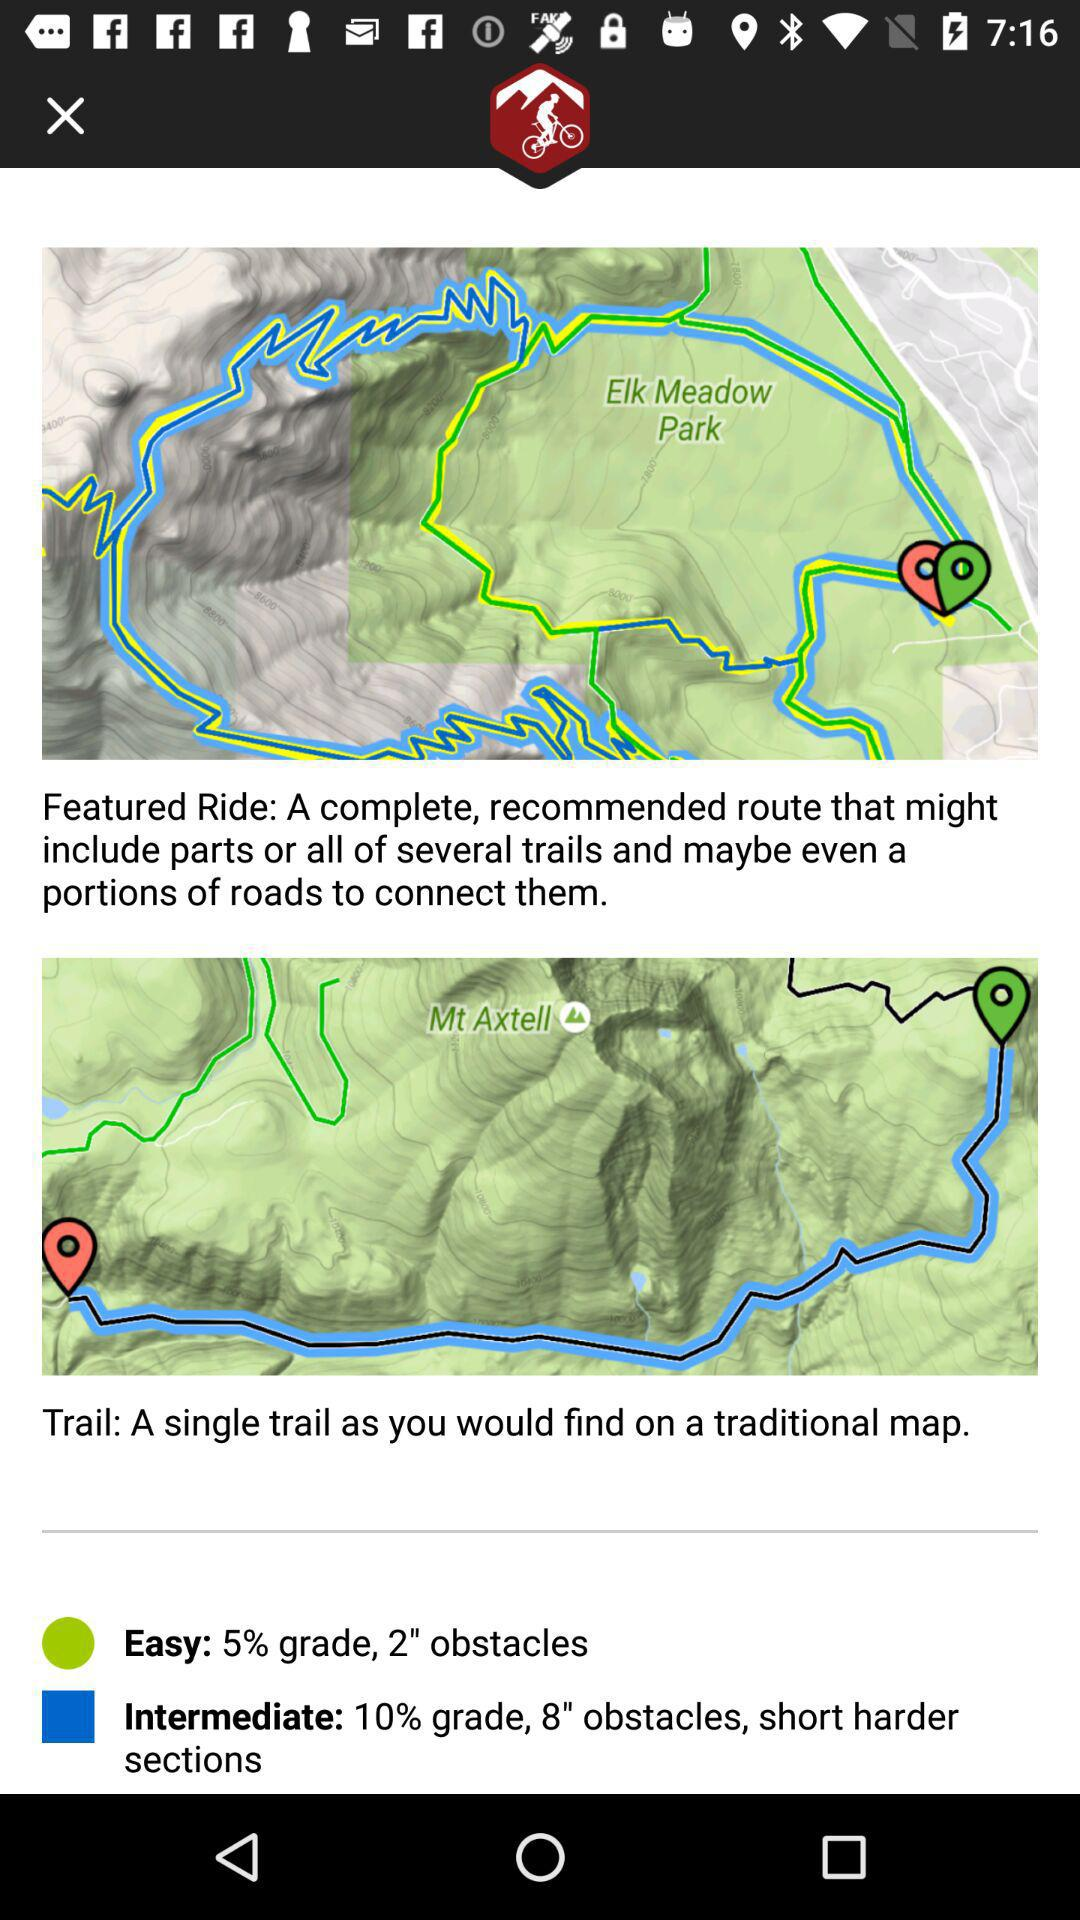What is the grade percentage in "Intermediate"? The grade percentage in "Intermediate" is 10. 